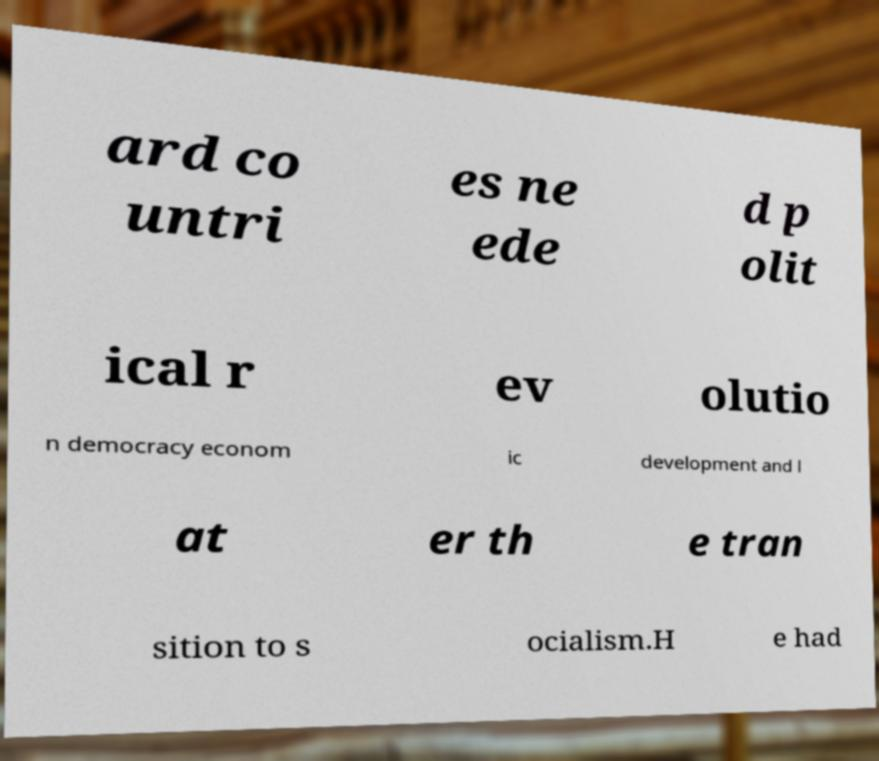Can you accurately transcribe the text from the provided image for me? ard co untri es ne ede d p olit ical r ev olutio n democracy econom ic development and l at er th e tran sition to s ocialism.H e had 